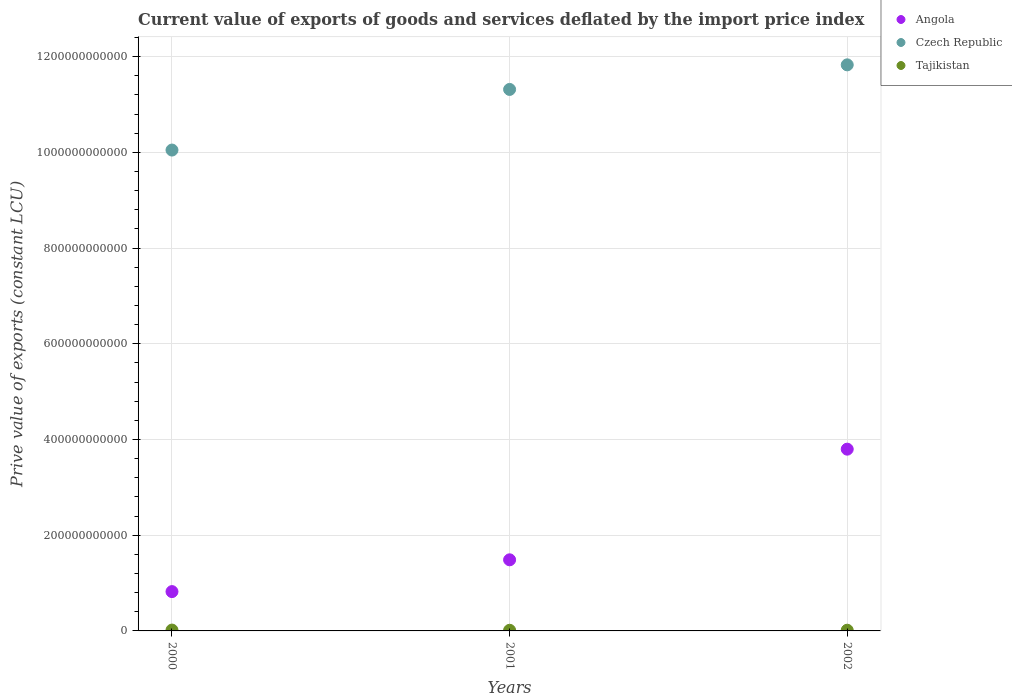Is the number of dotlines equal to the number of legend labels?
Ensure brevity in your answer.  Yes. What is the prive value of exports in Czech Republic in 2002?
Your answer should be very brief. 1.18e+12. Across all years, what is the maximum prive value of exports in Angola?
Make the answer very short. 3.80e+11. Across all years, what is the minimum prive value of exports in Czech Republic?
Provide a short and direct response. 1.00e+12. What is the total prive value of exports in Czech Republic in the graph?
Ensure brevity in your answer.  3.32e+12. What is the difference between the prive value of exports in Tajikistan in 2001 and that in 2002?
Offer a very short reply. -1.36e+08. What is the difference between the prive value of exports in Angola in 2002 and the prive value of exports in Czech Republic in 2000?
Keep it short and to the point. -6.25e+11. What is the average prive value of exports in Angola per year?
Your response must be concise. 2.04e+11. In the year 2000, what is the difference between the prive value of exports in Angola and prive value of exports in Czech Republic?
Offer a very short reply. -9.23e+11. In how many years, is the prive value of exports in Tajikistan greater than 840000000000 LCU?
Your answer should be compact. 0. What is the ratio of the prive value of exports in Czech Republic in 2000 to that in 2002?
Your answer should be very brief. 0.85. Is the prive value of exports in Tajikistan in 2000 less than that in 2001?
Your response must be concise. No. Is the difference between the prive value of exports in Angola in 2001 and 2002 greater than the difference between the prive value of exports in Czech Republic in 2001 and 2002?
Your answer should be compact. No. What is the difference between the highest and the second highest prive value of exports in Tajikistan?
Provide a succinct answer. 2.91e+08. What is the difference between the highest and the lowest prive value of exports in Angola?
Give a very brief answer. 2.98e+11. In how many years, is the prive value of exports in Czech Republic greater than the average prive value of exports in Czech Republic taken over all years?
Offer a very short reply. 2. Is the sum of the prive value of exports in Czech Republic in 2000 and 2002 greater than the maximum prive value of exports in Angola across all years?
Give a very brief answer. Yes. Is the prive value of exports in Tajikistan strictly greater than the prive value of exports in Czech Republic over the years?
Offer a very short reply. No. How many dotlines are there?
Keep it short and to the point. 3. How many years are there in the graph?
Keep it short and to the point. 3. What is the difference between two consecutive major ticks on the Y-axis?
Give a very brief answer. 2.00e+11. Does the graph contain any zero values?
Your answer should be compact. No. Where does the legend appear in the graph?
Keep it short and to the point. Top right. How many legend labels are there?
Give a very brief answer. 3. How are the legend labels stacked?
Your answer should be compact. Vertical. What is the title of the graph?
Your answer should be compact. Current value of exports of goods and services deflated by the import price index. What is the label or title of the Y-axis?
Give a very brief answer. Prive value of exports (constant LCU). What is the Prive value of exports (constant LCU) of Angola in 2000?
Provide a short and direct response. 8.22e+1. What is the Prive value of exports (constant LCU) in Czech Republic in 2000?
Provide a succinct answer. 1.00e+12. What is the Prive value of exports (constant LCU) in Tajikistan in 2000?
Keep it short and to the point. 1.76e+09. What is the Prive value of exports (constant LCU) of Angola in 2001?
Ensure brevity in your answer.  1.49e+11. What is the Prive value of exports (constant LCU) of Czech Republic in 2001?
Your response must be concise. 1.13e+12. What is the Prive value of exports (constant LCU) in Tajikistan in 2001?
Make the answer very short. 1.34e+09. What is the Prive value of exports (constant LCU) in Angola in 2002?
Your answer should be compact. 3.80e+11. What is the Prive value of exports (constant LCU) in Czech Republic in 2002?
Provide a short and direct response. 1.18e+12. What is the Prive value of exports (constant LCU) of Tajikistan in 2002?
Provide a succinct answer. 1.47e+09. Across all years, what is the maximum Prive value of exports (constant LCU) of Angola?
Your answer should be very brief. 3.80e+11. Across all years, what is the maximum Prive value of exports (constant LCU) in Czech Republic?
Your response must be concise. 1.18e+12. Across all years, what is the maximum Prive value of exports (constant LCU) in Tajikistan?
Make the answer very short. 1.76e+09. Across all years, what is the minimum Prive value of exports (constant LCU) of Angola?
Make the answer very short. 8.22e+1. Across all years, what is the minimum Prive value of exports (constant LCU) in Czech Republic?
Your answer should be compact. 1.00e+12. Across all years, what is the minimum Prive value of exports (constant LCU) of Tajikistan?
Ensure brevity in your answer.  1.34e+09. What is the total Prive value of exports (constant LCU) in Angola in the graph?
Keep it short and to the point. 6.11e+11. What is the total Prive value of exports (constant LCU) in Czech Republic in the graph?
Offer a very short reply. 3.32e+12. What is the total Prive value of exports (constant LCU) in Tajikistan in the graph?
Offer a terse response. 4.58e+09. What is the difference between the Prive value of exports (constant LCU) of Angola in 2000 and that in 2001?
Make the answer very short. -6.64e+1. What is the difference between the Prive value of exports (constant LCU) in Czech Republic in 2000 and that in 2001?
Provide a short and direct response. -1.27e+11. What is the difference between the Prive value of exports (constant LCU) in Tajikistan in 2000 and that in 2001?
Offer a very short reply. 4.27e+08. What is the difference between the Prive value of exports (constant LCU) of Angola in 2000 and that in 2002?
Provide a short and direct response. -2.98e+11. What is the difference between the Prive value of exports (constant LCU) in Czech Republic in 2000 and that in 2002?
Provide a short and direct response. -1.78e+11. What is the difference between the Prive value of exports (constant LCU) in Tajikistan in 2000 and that in 2002?
Offer a terse response. 2.91e+08. What is the difference between the Prive value of exports (constant LCU) of Angola in 2001 and that in 2002?
Make the answer very short. -2.31e+11. What is the difference between the Prive value of exports (constant LCU) in Czech Republic in 2001 and that in 2002?
Keep it short and to the point. -5.14e+1. What is the difference between the Prive value of exports (constant LCU) of Tajikistan in 2001 and that in 2002?
Your answer should be very brief. -1.36e+08. What is the difference between the Prive value of exports (constant LCU) in Angola in 2000 and the Prive value of exports (constant LCU) in Czech Republic in 2001?
Offer a very short reply. -1.05e+12. What is the difference between the Prive value of exports (constant LCU) of Angola in 2000 and the Prive value of exports (constant LCU) of Tajikistan in 2001?
Provide a succinct answer. 8.08e+1. What is the difference between the Prive value of exports (constant LCU) in Czech Republic in 2000 and the Prive value of exports (constant LCU) in Tajikistan in 2001?
Make the answer very short. 1.00e+12. What is the difference between the Prive value of exports (constant LCU) in Angola in 2000 and the Prive value of exports (constant LCU) in Czech Republic in 2002?
Your answer should be very brief. -1.10e+12. What is the difference between the Prive value of exports (constant LCU) in Angola in 2000 and the Prive value of exports (constant LCU) in Tajikistan in 2002?
Your response must be concise. 8.07e+1. What is the difference between the Prive value of exports (constant LCU) in Czech Republic in 2000 and the Prive value of exports (constant LCU) in Tajikistan in 2002?
Ensure brevity in your answer.  1.00e+12. What is the difference between the Prive value of exports (constant LCU) in Angola in 2001 and the Prive value of exports (constant LCU) in Czech Republic in 2002?
Provide a short and direct response. -1.03e+12. What is the difference between the Prive value of exports (constant LCU) of Angola in 2001 and the Prive value of exports (constant LCU) of Tajikistan in 2002?
Your response must be concise. 1.47e+11. What is the difference between the Prive value of exports (constant LCU) in Czech Republic in 2001 and the Prive value of exports (constant LCU) in Tajikistan in 2002?
Ensure brevity in your answer.  1.13e+12. What is the average Prive value of exports (constant LCU) of Angola per year?
Make the answer very short. 2.04e+11. What is the average Prive value of exports (constant LCU) of Czech Republic per year?
Ensure brevity in your answer.  1.11e+12. What is the average Prive value of exports (constant LCU) in Tajikistan per year?
Ensure brevity in your answer.  1.53e+09. In the year 2000, what is the difference between the Prive value of exports (constant LCU) in Angola and Prive value of exports (constant LCU) in Czech Republic?
Your answer should be very brief. -9.23e+11. In the year 2000, what is the difference between the Prive value of exports (constant LCU) of Angola and Prive value of exports (constant LCU) of Tajikistan?
Ensure brevity in your answer.  8.04e+1. In the year 2000, what is the difference between the Prive value of exports (constant LCU) of Czech Republic and Prive value of exports (constant LCU) of Tajikistan?
Your response must be concise. 1.00e+12. In the year 2001, what is the difference between the Prive value of exports (constant LCU) in Angola and Prive value of exports (constant LCU) in Czech Republic?
Your answer should be compact. -9.83e+11. In the year 2001, what is the difference between the Prive value of exports (constant LCU) in Angola and Prive value of exports (constant LCU) in Tajikistan?
Provide a short and direct response. 1.47e+11. In the year 2001, what is the difference between the Prive value of exports (constant LCU) in Czech Republic and Prive value of exports (constant LCU) in Tajikistan?
Offer a terse response. 1.13e+12. In the year 2002, what is the difference between the Prive value of exports (constant LCU) in Angola and Prive value of exports (constant LCU) in Czech Republic?
Offer a terse response. -8.03e+11. In the year 2002, what is the difference between the Prive value of exports (constant LCU) of Angola and Prive value of exports (constant LCU) of Tajikistan?
Your response must be concise. 3.78e+11. In the year 2002, what is the difference between the Prive value of exports (constant LCU) in Czech Republic and Prive value of exports (constant LCU) in Tajikistan?
Provide a short and direct response. 1.18e+12. What is the ratio of the Prive value of exports (constant LCU) in Angola in 2000 to that in 2001?
Ensure brevity in your answer.  0.55. What is the ratio of the Prive value of exports (constant LCU) of Czech Republic in 2000 to that in 2001?
Offer a very short reply. 0.89. What is the ratio of the Prive value of exports (constant LCU) in Tajikistan in 2000 to that in 2001?
Provide a succinct answer. 1.32. What is the ratio of the Prive value of exports (constant LCU) of Angola in 2000 to that in 2002?
Make the answer very short. 0.22. What is the ratio of the Prive value of exports (constant LCU) of Czech Republic in 2000 to that in 2002?
Give a very brief answer. 0.85. What is the ratio of the Prive value of exports (constant LCU) in Tajikistan in 2000 to that in 2002?
Offer a very short reply. 1.2. What is the ratio of the Prive value of exports (constant LCU) of Angola in 2001 to that in 2002?
Make the answer very short. 0.39. What is the ratio of the Prive value of exports (constant LCU) of Czech Republic in 2001 to that in 2002?
Your answer should be very brief. 0.96. What is the ratio of the Prive value of exports (constant LCU) in Tajikistan in 2001 to that in 2002?
Your answer should be very brief. 0.91. What is the difference between the highest and the second highest Prive value of exports (constant LCU) in Angola?
Your response must be concise. 2.31e+11. What is the difference between the highest and the second highest Prive value of exports (constant LCU) of Czech Republic?
Make the answer very short. 5.14e+1. What is the difference between the highest and the second highest Prive value of exports (constant LCU) in Tajikistan?
Provide a succinct answer. 2.91e+08. What is the difference between the highest and the lowest Prive value of exports (constant LCU) of Angola?
Your answer should be compact. 2.98e+11. What is the difference between the highest and the lowest Prive value of exports (constant LCU) of Czech Republic?
Offer a very short reply. 1.78e+11. What is the difference between the highest and the lowest Prive value of exports (constant LCU) in Tajikistan?
Give a very brief answer. 4.27e+08. 